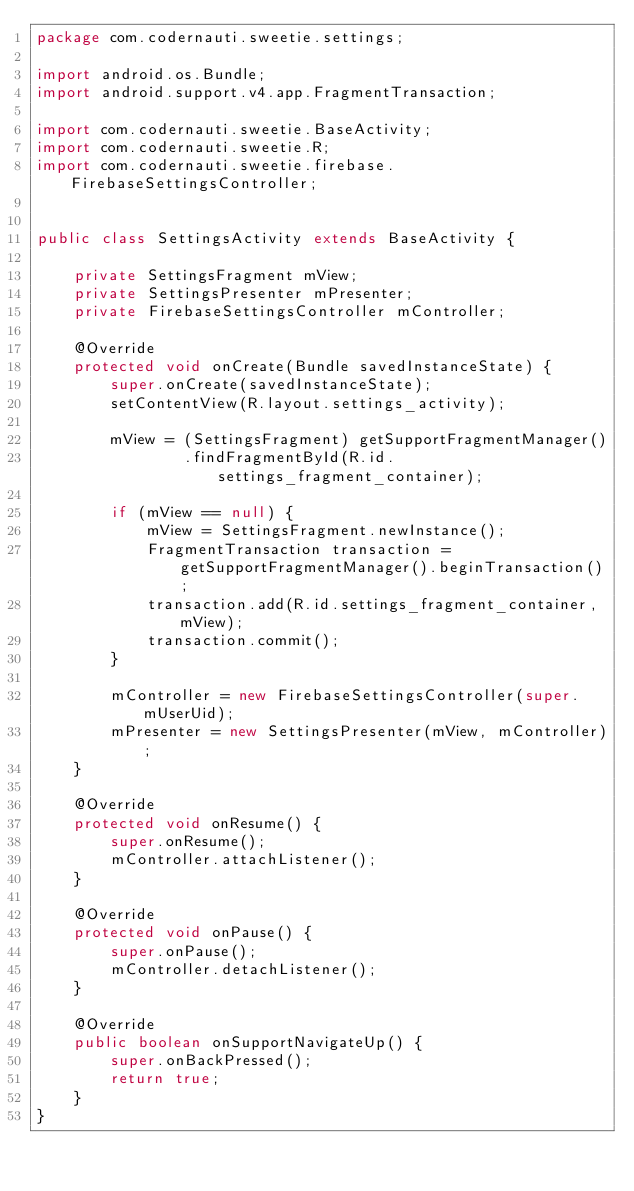<code> <loc_0><loc_0><loc_500><loc_500><_Java_>package com.codernauti.sweetie.settings;

import android.os.Bundle;
import android.support.v4.app.FragmentTransaction;

import com.codernauti.sweetie.BaseActivity;
import com.codernauti.sweetie.R;
import com.codernauti.sweetie.firebase.FirebaseSettingsController;


public class SettingsActivity extends BaseActivity {

    private SettingsFragment mView;
    private SettingsPresenter mPresenter;
    private FirebaseSettingsController mController;

    @Override
    protected void onCreate(Bundle savedInstanceState) {
        super.onCreate(savedInstanceState);
        setContentView(R.layout.settings_activity);

        mView = (SettingsFragment) getSupportFragmentManager()
                .findFragmentById(R.id.settings_fragment_container);

        if (mView == null) {
            mView = SettingsFragment.newInstance();
            FragmentTransaction transaction = getSupportFragmentManager().beginTransaction();
            transaction.add(R.id.settings_fragment_container, mView);
            transaction.commit();
        }

        mController = new FirebaseSettingsController(super.mUserUid);
        mPresenter = new SettingsPresenter(mView, mController);
    }

    @Override
    protected void onResume() {
        super.onResume();
        mController.attachListener();
    }

    @Override
    protected void onPause() {
        super.onPause();
        mController.detachListener();
    }

    @Override
    public boolean onSupportNavigateUp() {
        super.onBackPressed();
        return true;
    }
}
</code> 